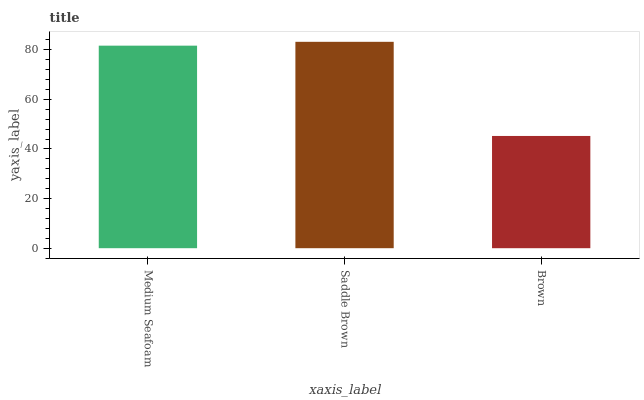Is Brown the minimum?
Answer yes or no. Yes. Is Saddle Brown the maximum?
Answer yes or no. Yes. Is Saddle Brown the minimum?
Answer yes or no. No. Is Brown the maximum?
Answer yes or no. No. Is Saddle Brown greater than Brown?
Answer yes or no. Yes. Is Brown less than Saddle Brown?
Answer yes or no. Yes. Is Brown greater than Saddle Brown?
Answer yes or no. No. Is Saddle Brown less than Brown?
Answer yes or no. No. Is Medium Seafoam the high median?
Answer yes or no. Yes. Is Medium Seafoam the low median?
Answer yes or no. Yes. Is Saddle Brown the high median?
Answer yes or no. No. Is Saddle Brown the low median?
Answer yes or no. No. 